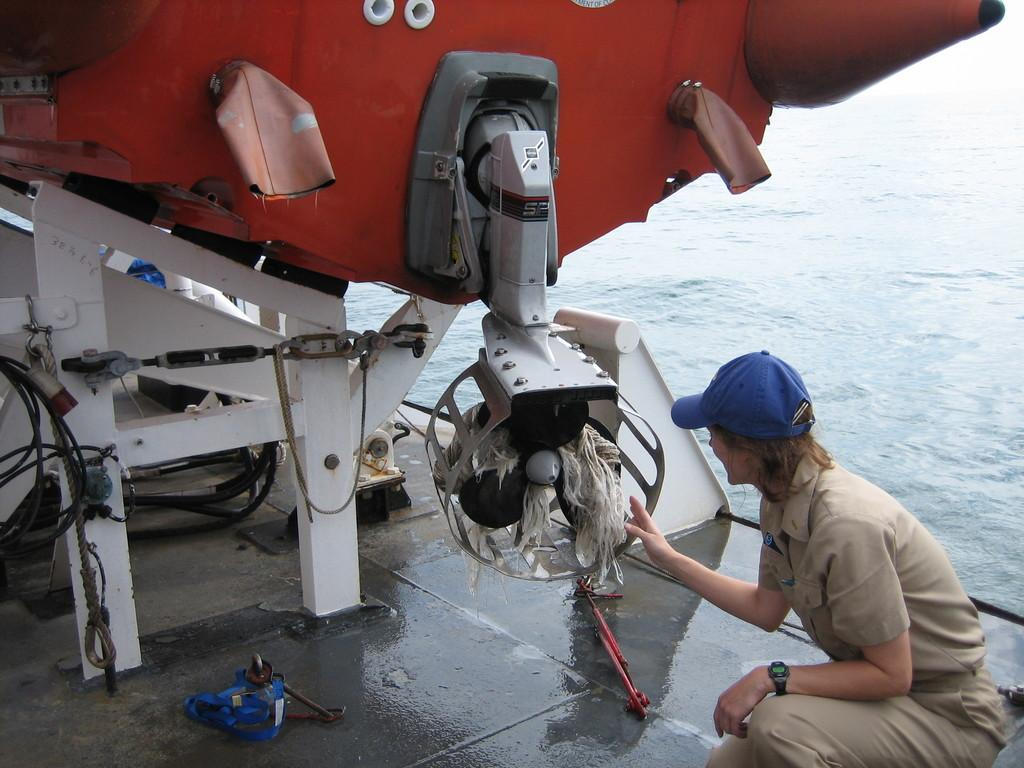What is the main subject of the image? There is a boat in the image. Can you describe the woman on the right side of the image? The woman is wearing a cap and a watch. What is the woman's position in relation to the boat? The woman is on the right side of the image. What can be seen at the bottom of the image? There is water visible at the bottom of the image. What object is present in the image that might be used for tying or securing? There is a rope in the image. What type of can is visible on the boat in the image? There is no can present on the boat in the image. Can you tell me how many coaches are in the image? There are no coaches present in the image. 